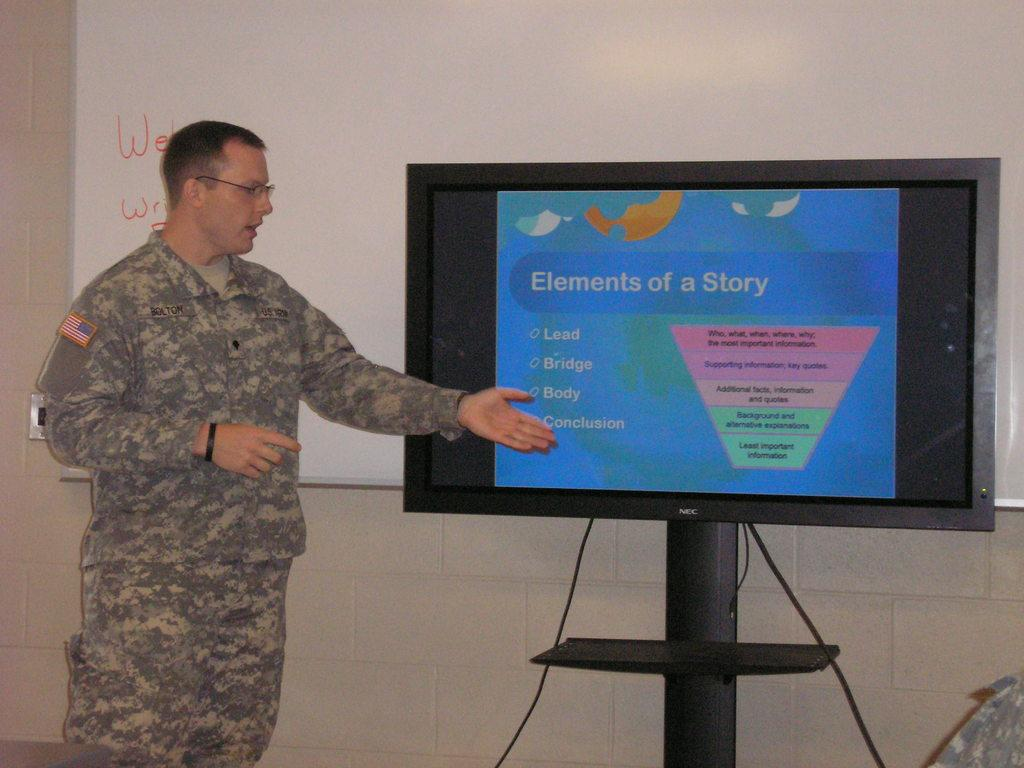What is the man doing in the image? The man is standing beside a TV screen and explaining something. What might be used to display visual aids or information in the image? There is a whiteboard on the wall in the image. What type of rifle is the man holding in the image? There is no rifle present in the image; the man is standing beside a TV screen and explaining something. How many crows can be seen on the man's face in the image? There are no crows present on the man's face in the image. 